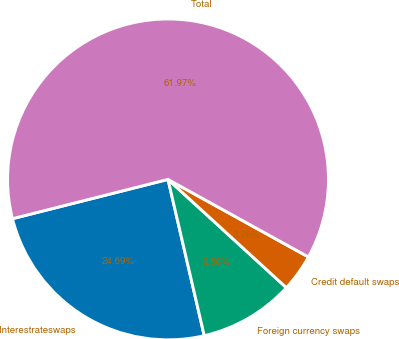Convert chart. <chart><loc_0><loc_0><loc_500><loc_500><pie_chart><fcel>Interestrateswaps<fcel>Foreign currency swaps<fcel>Credit default swaps<fcel>Total<nl><fcel>24.69%<fcel>9.58%<fcel>3.76%<fcel>61.98%<nl></chart> 